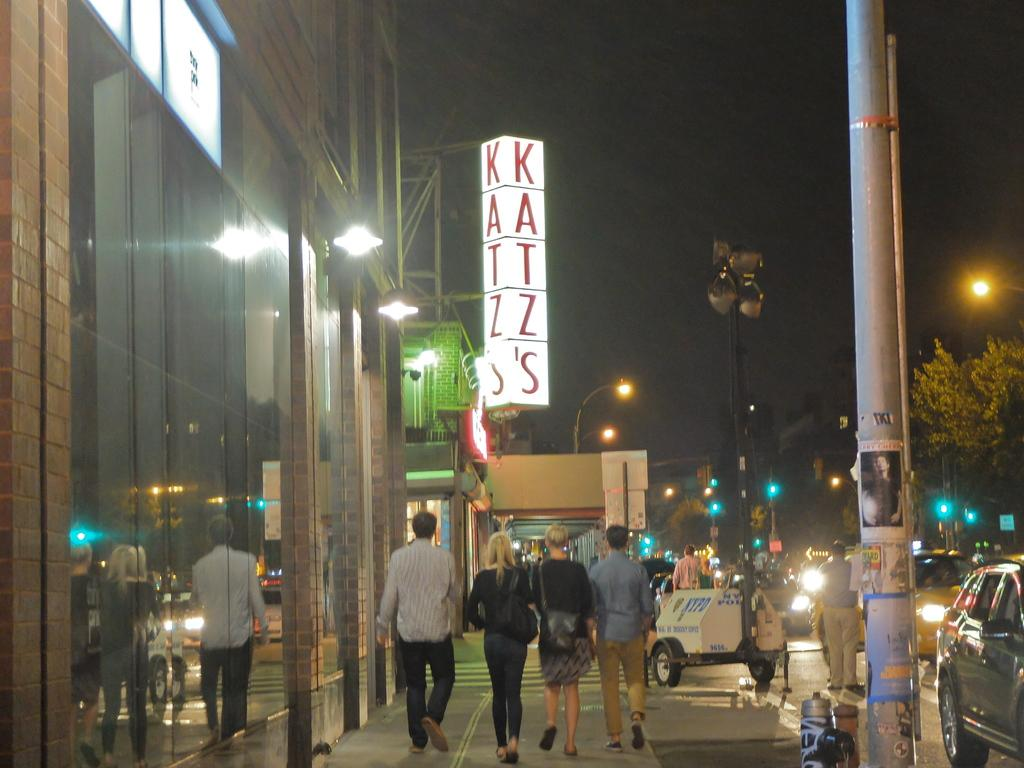What are the people in the image doing? The people in the image are walking on the road. What else can be seen on the road in the image? Vehicles are also present on the road in the image. What type of natural elements are visible in the image? Trees are present in the image. What type of structures are visible in the image? Light-poles, poles, and glass buildings are visible in the image. What else can be seen in the image? Boards are visible in the image. What type of grain is being tasted by the man in the image? There is no man or grain present in the image. What is the taste of the grain being consumed by the man in the image? There is no man or grain present in the image, so it is not possible to determine the taste. 